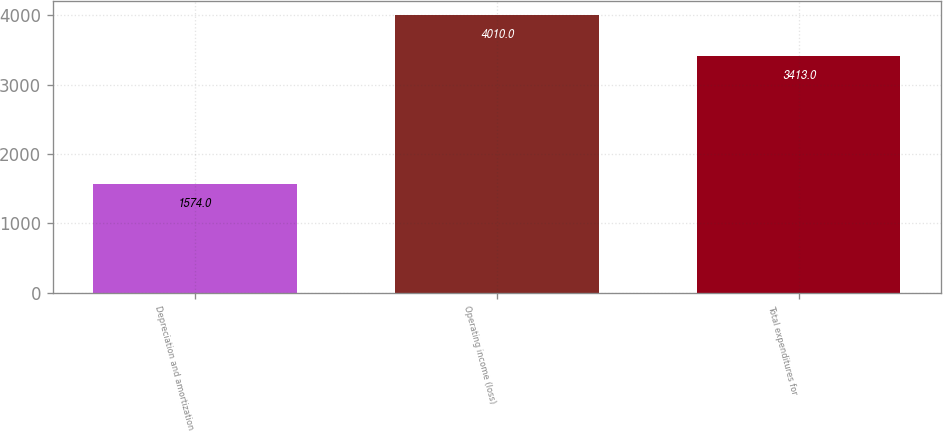<chart> <loc_0><loc_0><loc_500><loc_500><bar_chart><fcel>Depreciation and amortization<fcel>Operating income (loss)<fcel>Total expenditures for<nl><fcel>1574<fcel>4010<fcel>3413<nl></chart> 